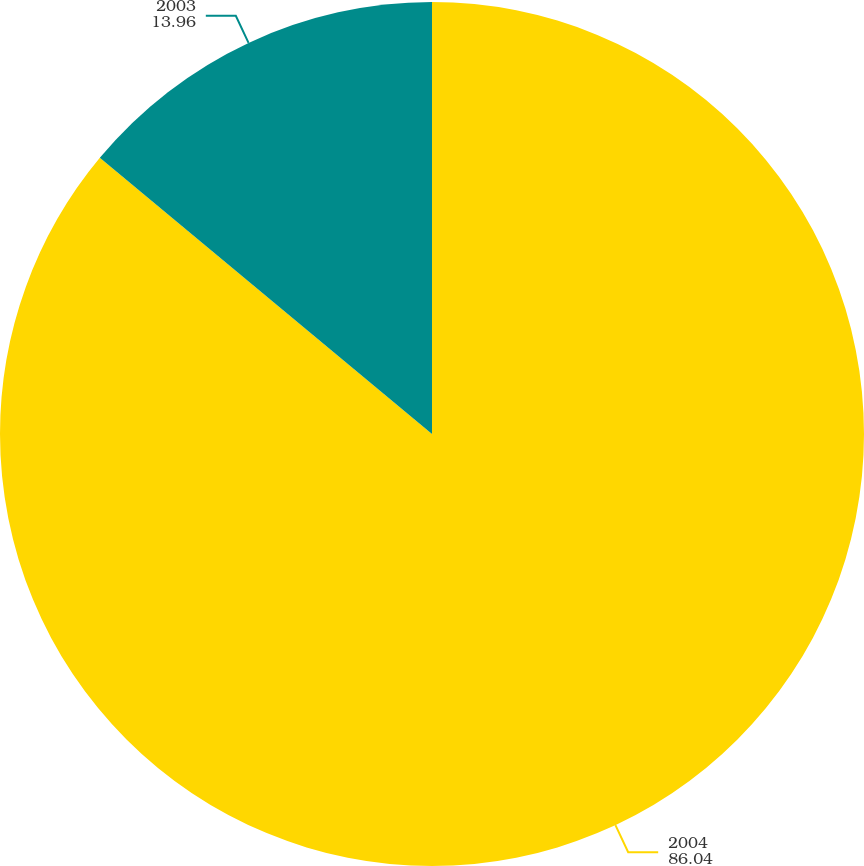Convert chart to OTSL. <chart><loc_0><loc_0><loc_500><loc_500><pie_chart><fcel>2004<fcel>2003<nl><fcel>86.04%<fcel>13.96%<nl></chart> 